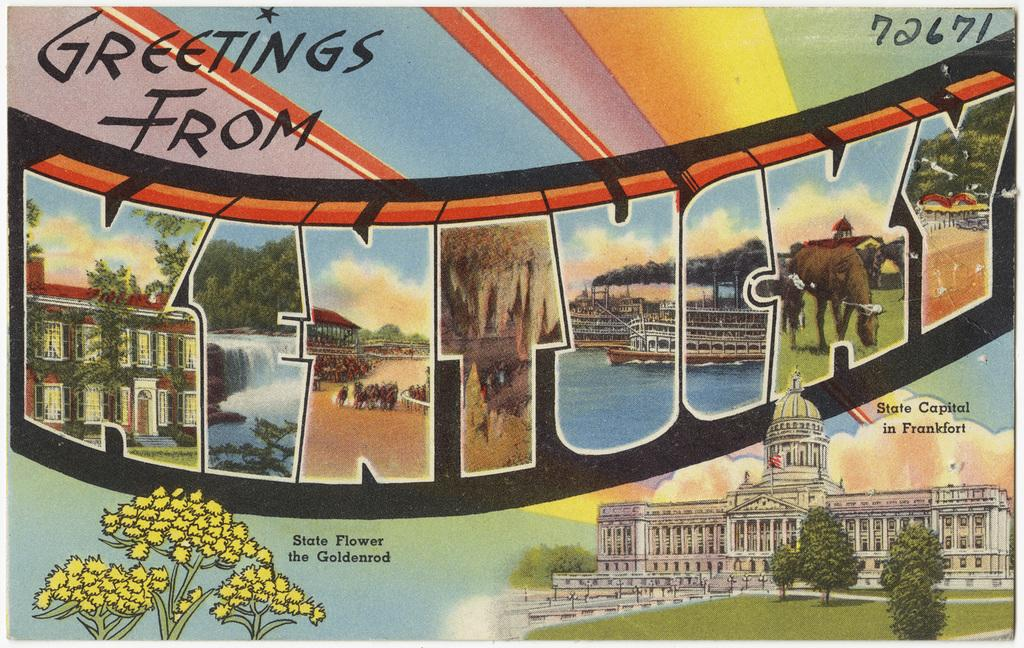Provide a one-sentence caption for the provided image. A postcard with a graphic that reads, "Greetings from Kentucky.:. 